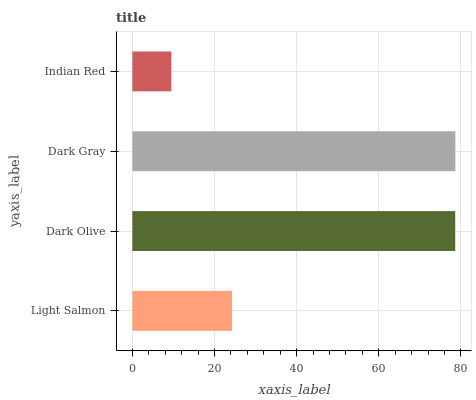Is Indian Red the minimum?
Answer yes or no. Yes. Is Dark Gray the maximum?
Answer yes or no. Yes. Is Dark Olive the minimum?
Answer yes or no. No. Is Dark Olive the maximum?
Answer yes or no. No. Is Dark Olive greater than Light Salmon?
Answer yes or no. Yes. Is Light Salmon less than Dark Olive?
Answer yes or no. Yes. Is Light Salmon greater than Dark Olive?
Answer yes or no. No. Is Dark Olive less than Light Salmon?
Answer yes or no. No. Is Dark Olive the high median?
Answer yes or no. Yes. Is Light Salmon the low median?
Answer yes or no. Yes. Is Light Salmon the high median?
Answer yes or no. No. Is Indian Red the low median?
Answer yes or no. No. 